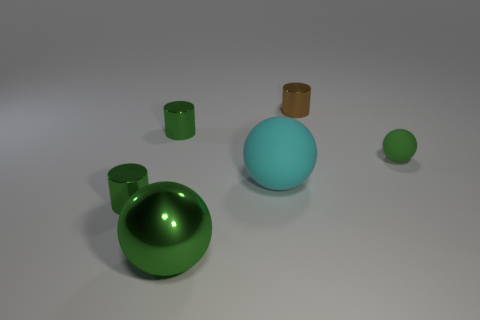Subtract all brown spheres. Subtract all blue cylinders. How many spheres are left? 3 Add 4 large cyan objects. How many objects exist? 10 Subtract all brown cylinders. Subtract all small green balls. How many objects are left? 4 Add 4 metal cylinders. How many metal cylinders are left? 7 Add 3 large green shiny things. How many large green shiny things exist? 4 Subtract 0 brown spheres. How many objects are left? 6 